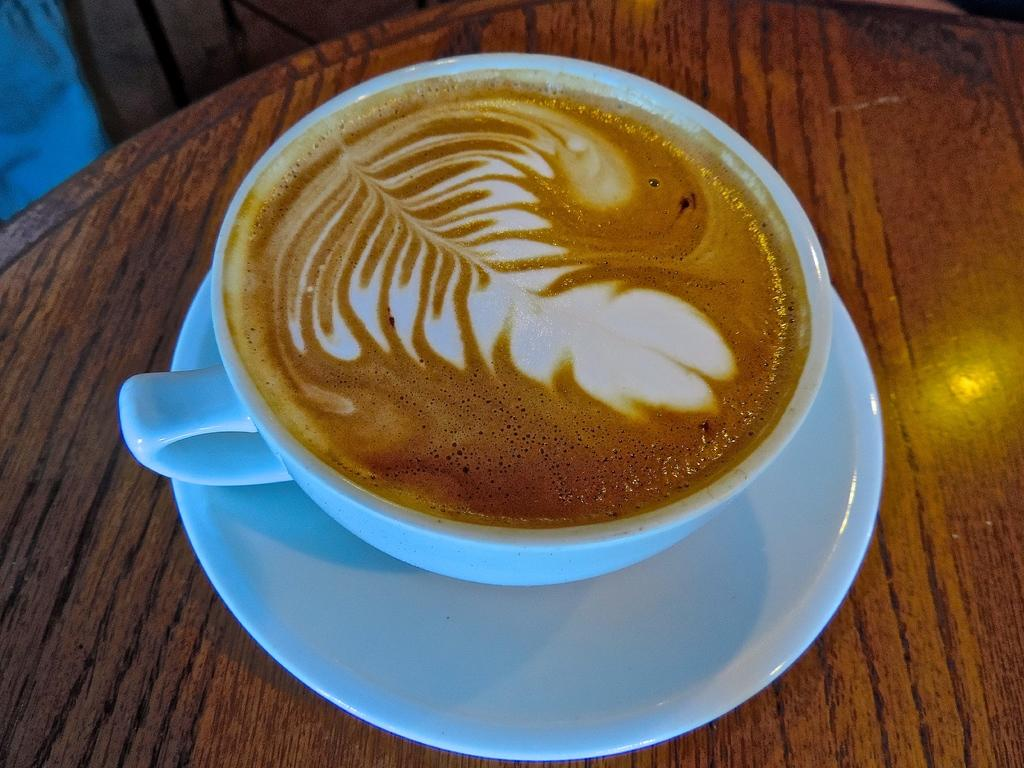What is in the cup that is visible in the image? There is coffee in the cup. How is the cup positioned in the image? The cup is in a saucer. Where is the saucer located in the image? The saucer is on a table. What type of vegetable is being used as a riddle in the image? There is no vegetable or riddle present in the image. Can you see a crow in the image? There is no crow present in the image. 